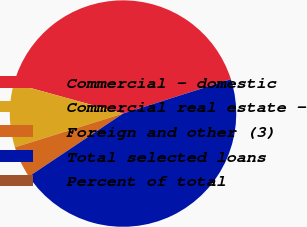<chart> <loc_0><loc_0><loc_500><loc_500><pie_chart><fcel>Commercial - domestic<fcel>Commercial real estate -<fcel>Foreign and other (3)<fcel>Total selected loans<fcel>Percent of total<nl><fcel>40.79%<fcel>9.11%<fcel>4.56%<fcel>45.52%<fcel>0.01%<nl></chart> 